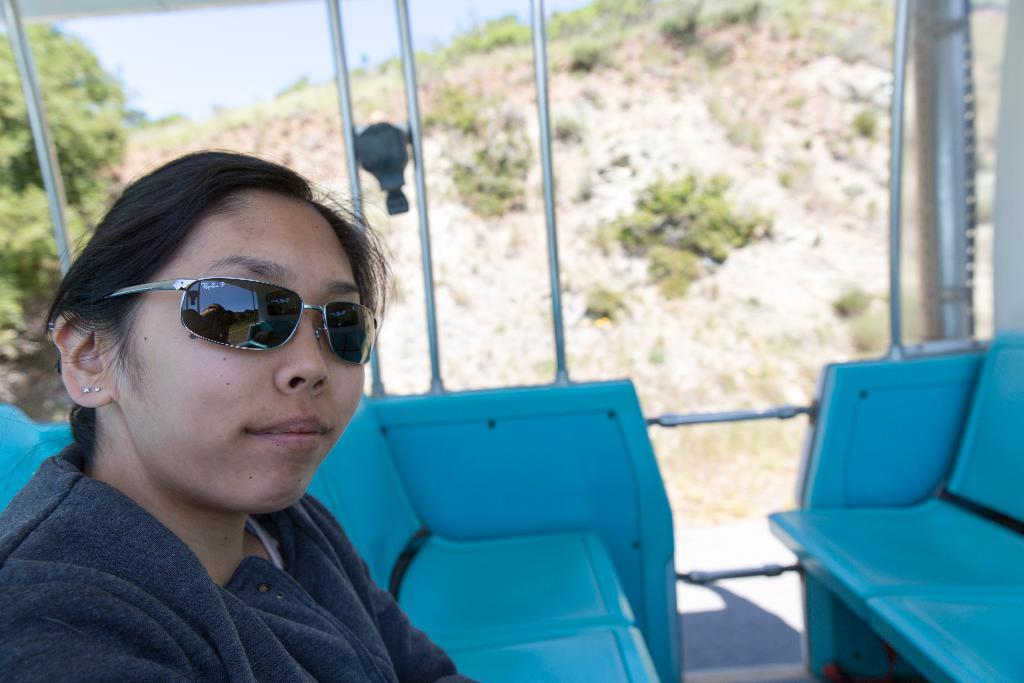Who is present in the image? There is a woman in the image. What is the woman wearing on her face? The woman is wearing goggles. What type of furniture can be seen in the image? There are chairs in the image. What can be seen in the background of the image? There are trees and plants in the background of the image. What type of skirt is the woman wearing in the image? The provided facts do not mention a skirt; the woman is wearing goggles. What religion is being practiced in the image? There is no indication of any religious practice in the image. 